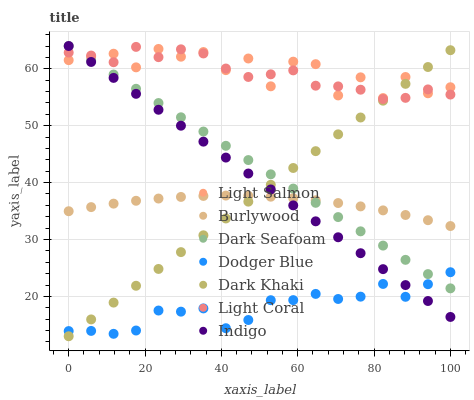Does Dodger Blue have the minimum area under the curve?
Answer yes or no. Yes. Does Light Salmon have the maximum area under the curve?
Answer yes or no. Yes. Does Indigo have the minimum area under the curve?
Answer yes or no. No. Does Indigo have the maximum area under the curve?
Answer yes or no. No. Is Dark Khaki the smoothest?
Answer yes or no. Yes. Is Light Salmon the roughest?
Answer yes or no. Yes. Is Indigo the smoothest?
Answer yes or no. No. Is Indigo the roughest?
Answer yes or no. No. Does Dark Khaki have the lowest value?
Answer yes or no. Yes. Does Indigo have the lowest value?
Answer yes or no. No. Does Dark Seafoam have the highest value?
Answer yes or no. Yes. Does Light Salmon have the highest value?
Answer yes or no. No. Is Burlywood less than Light Coral?
Answer yes or no. Yes. Is Light Salmon greater than Burlywood?
Answer yes or no. Yes. Does Dark Seafoam intersect Light Coral?
Answer yes or no. Yes. Is Dark Seafoam less than Light Coral?
Answer yes or no. No. Is Dark Seafoam greater than Light Coral?
Answer yes or no. No. Does Burlywood intersect Light Coral?
Answer yes or no. No. 